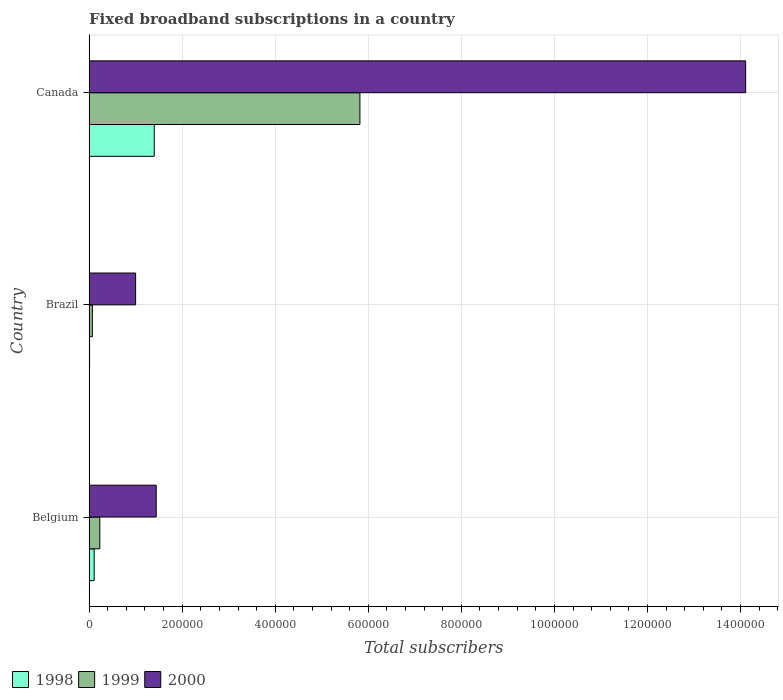How many bars are there on the 3rd tick from the bottom?
Provide a short and direct response. 3. What is the number of broadband subscriptions in 1998 in Canada?
Provide a short and direct response. 1.40e+05. Across all countries, what is the maximum number of broadband subscriptions in 2000?
Your answer should be very brief. 1.41e+06. Across all countries, what is the minimum number of broadband subscriptions in 2000?
Ensure brevity in your answer.  1.00e+05. In which country was the number of broadband subscriptions in 1998 minimum?
Offer a very short reply. Brazil. What is the total number of broadband subscriptions in 2000 in the graph?
Keep it short and to the point. 1.66e+06. What is the difference between the number of broadband subscriptions in 1999 in Brazil and that in Canada?
Make the answer very short. -5.75e+05. What is the difference between the number of broadband subscriptions in 2000 in Canada and the number of broadband subscriptions in 1999 in Brazil?
Provide a short and direct response. 1.40e+06. What is the average number of broadband subscriptions in 2000 per country?
Offer a very short reply. 5.52e+05. What is the difference between the number of broadband subscriptions in 1999 and number of broadband subscriptions in 2000 in Belgium?
Your answer should be compact. -1.21e+05. What is the ratio of the number of broadband subscriptions in 1999 in Belgium to that in Brazil?
Provide a succinct answer. 3.29. Is the number of broadband subscriptions in 1999 in Belgium less than that in Canada?
Your answer should be compact. Yes. What is the difference between the highest and the second highest number of broadband subscriptions in 2000?
Your answer should be very brief. 1.27e+06. What is the difference between the highest and the lowest number of broadband subscriptions in 2000?
Offer a very short reply. 1.31e+06. In how many countries, is the number of broadband subscriptions in 2000 greater than the average number of broadband subscriptions in 2000 taken over all countries?
Your response must be concise. 1. What does the 1st bar from the top in Brazil represents?
Give a very brief answer. 2000. Is it the case that in every country, the sum of the number of broadband subscriptions in 1999 and number of broadband subscriptions in 2000 is greater than the number of broadband subscriptions in 1998?
Provide a succinct answer. Yes. What is the difference between two consecutive major ticks on the X-axis?
Offer a very short reply. 2.00e+05. Does the graph contain any zero values?
Your answer should be very brief. No. How many legend labels are there?
Provide a short and direct response. 3. How are the legend labels stacked?
Keep it short and to the point. Horizontal. What is the title of the graph?
Keep it short and to the point. Fixed broadband subscriptions in a country. What is the label or title of the X-axis?
Your answer should be compact. Total subscribers. What is the label or title of the Y-axis?
Make the answer very short. Country. What is the Total subscribers of 1998 in Belgium?
Your response must be concise. 1.09e+04. What is the Total subscribers of 1999 in Belgium?
Offer a very short reply. 2.30e+04. What is the Total subscribers of 2000 in Belgium?
Provide a short and direct response. 1.44e+05. What is the Total subscribers of 1998 in Brazil?
Keep it short and to the point. 1000. What is the Total subscribers of 1999 in Brazil?
Your answer should be very brief. 7000. What is the Total subscribers of 2000 in Brazil?
Ensure brevity in your answer.  1.00e+05. What is the Total subscribers of 1999 in Canada?
Give a very brief answer. 5.82e+05. What is the Total subscribers in 2000 in Canada?
Your answer should be compact. 1.41e+06. Across all countries, what is the maximum Total subscribers in 1999?
Ensure brevity in your answer.  5.82e+05. Across all countries, what is the maximum Total subscribers in 2000?
Provide a short and direct response. 1.41e+06. Across all countries, what is the minimum Total subscribers in 1998?
Offer a very short reply. 1000. Across all countries, what is the minimum Total subscribers in 1999?
Your answer should be very brief. 7000. Across all countries, what is the minimum Total subscribers in 2000?
Keep it short and to the point. 1.00e+05. What is the total Total subscribers in 1998 in the graph?
Your response must be concise. 1.52e+05. What is the total Total subscribers of 1999 in the graph?
Your response must be concise. 6.12e+05. What is the total Total subscribers in 2000 in the graph?
Offer a very short reply. 1.66e+06. What is the difference between the Total subscribers in 1998 in Belgium and that in Brazil?
Provide a short and direct response. 9924. What is the difference between the Total subscribers in 1999 in Belgium and that in Brazil?
Keep it short and to the point. 1.60e+04. What is the difference between the Total subscribers of 2000 in Belgium and that in Brazil?
Give a very brief answer. 4.42e+04. What is the difference between the Total subscribers of 1998 in Belgium and that in Canada?
Offer a terse response. -1.29e+05. What is the difference between the Total subscribers in 1999 in Belgium and that in Canada?
Provide a succinct answer. -5.59e+05. What is the difference between the Total subscribers in 2000 in Belgium and that in Canada?
Offer a very short reply. -1.27e+06. What is the difference between the Total subscribers of 1998 in Brazil and that in Canada?
Your answer should be compact. -1.39e+05. What is the difference between the Total subscribers in 1999 in Brazil and that in Canada?
Your response must be concise. -5.75e+05. What is the difference between the Total subscribers in 2000 in Brazil and that in Canada?
Ensure brevity in your answer.  -1.31e+06. What is the difference between the Total subscribers of 1998 in Belgium and the Total subscribers of 1999 in Brazil?
Make the answer very short. 3924. What is the difference between the Total subscribers in 1998 in Belgium and the Total subscribers in 2000 in Brazil?
Give a very brief answer. -8.91e+04. What is the difference between the Total subscribers of 1999 in Belgium and the Total subscribers of 2000 in Brazil?
Offer a terse response. -7.70e+04. What is the difference between the Total subscribers in 1998 in Belgium and the Total subscribers in 1999 in Canada?
Your answer should be very brief. -5.71e+05. What is the difference between the Total subscribers in 1998 in Belgium and the Total subscribers in 2000 in Canada?
Make the answer very short. -1.40e+06. What is the difference between the Total subscribers in 1999 in Belgium and the Total subscribers in 2000 in Canada?
Make the answer very short. -1.39e+06. What is the difference between the Total subscribers in 1998 in Brazil and the Total subscribers in 1999 in Canada?
Provide a short and direct response. -5.81e+05. What is the difference between the Total subscribers in 1998 in Brazil and the Total subscribers in 2000 in Canada?
Your answer should be very brief. -1.41e+06. What is the difference between the Total subscribers in 1999 in Brazil and the Total subscribers in 2000 in Canada?
Provide a short and direct response. -1.40e+06. What is the average Total subscribers of 1998 per country?
Your answer should be compact. 5.06e+04. What is the average Total subscribers of 1999 per country?
Keep it short and to the point. 2.04e+05. What is the average Total subscribers in 2000 per country?
Your response must be concise. 5.52e+05. What is the difference between the Total subscribers in 1998 and Total subscribers in 1999 in Belgium?
Your response must be concise. -1.21e+04. What is the difference between the Total subscribers of 1998 and Total subscribers of 2000 in Belgium?
Your answer should be compact. -1.33e+05. What is the difference between the Total subscribers of 1999 and Total subscribers of 2000 in Belgium?
Provide a short and direct response. -1.21e+05. What is the difference between the Total subscribers in 1998 and Total subscribers in 1999 in Brazil?
Give a very brief answer. -6000. What is the difference between the Total subscribers in 1998 and Total subscribers in 2000 in Brazil?
Your answer should be compact. -9.90e+04. What is the difference between the Total subscribers in 1999 and Total subscribers in 2000 in Brazil?
Make the answer very short. -9.30e+04. What is the difference between the Total subscribers of 1998 and Total subscribers of 1999 in Canada?
Ensure brevity in your answer.  -4.42e+05. What is the difference between the Total subscribers in 1998 and Total subscribers in 2000 in Canada?
Keep it short and to the point. -1.27e+06. What is the difference between the Total subscribers in 1999 and Total subscribers in 2000 in Canada?
Keep it short and to the point. -8.29e+05. What is the ratio of the Total subscribers in 1998 in Belgium to that in Brazil?
Offer a very short reply. 10.92. What is the ratio of the Total subscribers in 1999 in Belgium to that in Brazil?
Your answer should be very brief. 3.29. What is the ratio of the Total subscribers of 2000 in Belgium to that in Brazil?
Ensure brevity in your answer.  1.44. What is the ratio of the Total subscribers in 1998 in Belgium to that in Canada?
Make the answer very short. 0.08. What is the ratio of the Total subscribers of 1999 in Belgium to that in Canada?
Your answer should be compact. 0.04. What is the ratio of the Total subscribers in 2000 in Belgium to that in Canada?
Provide a short and direct response. 0.1. What is the ratio of the Total subscribers of 1998 in Brazil to that in Canada?
Make the answer very short. 0.01. What is the ratio of the Total subscribers in 1999 in Brazil to that in Canada?
Ensure brevity in your answer.  0.01. What is the ratio of the Total subscribers in 2000 in Brazil to that in Canada?
Keep it short and to the point. 0.07. What is the difference between the highest and the second highest Total subscribers in 1998?
Provide a short and direct response. 1.29e+05. What is the difference between the highest and the second highest Total subscribers in 1999?
Your response must be concise. 5.59e+05. What is the difference between the highest and the second highest Total subscribers in 2000?
Your response must be concise. 1.27e+06. What is the difference between the highest and the lowest Total subscribers of 1998?
Your answer should be compact. 1.39e+05. What is the difference between the highest and the lowest Total subscribers of 1999?
Offer a terse response. 5.75e+05. What is the difference between the highest and the lowest Total subscribers of 2000?
Give a very brief answer. 1.31e+06. 